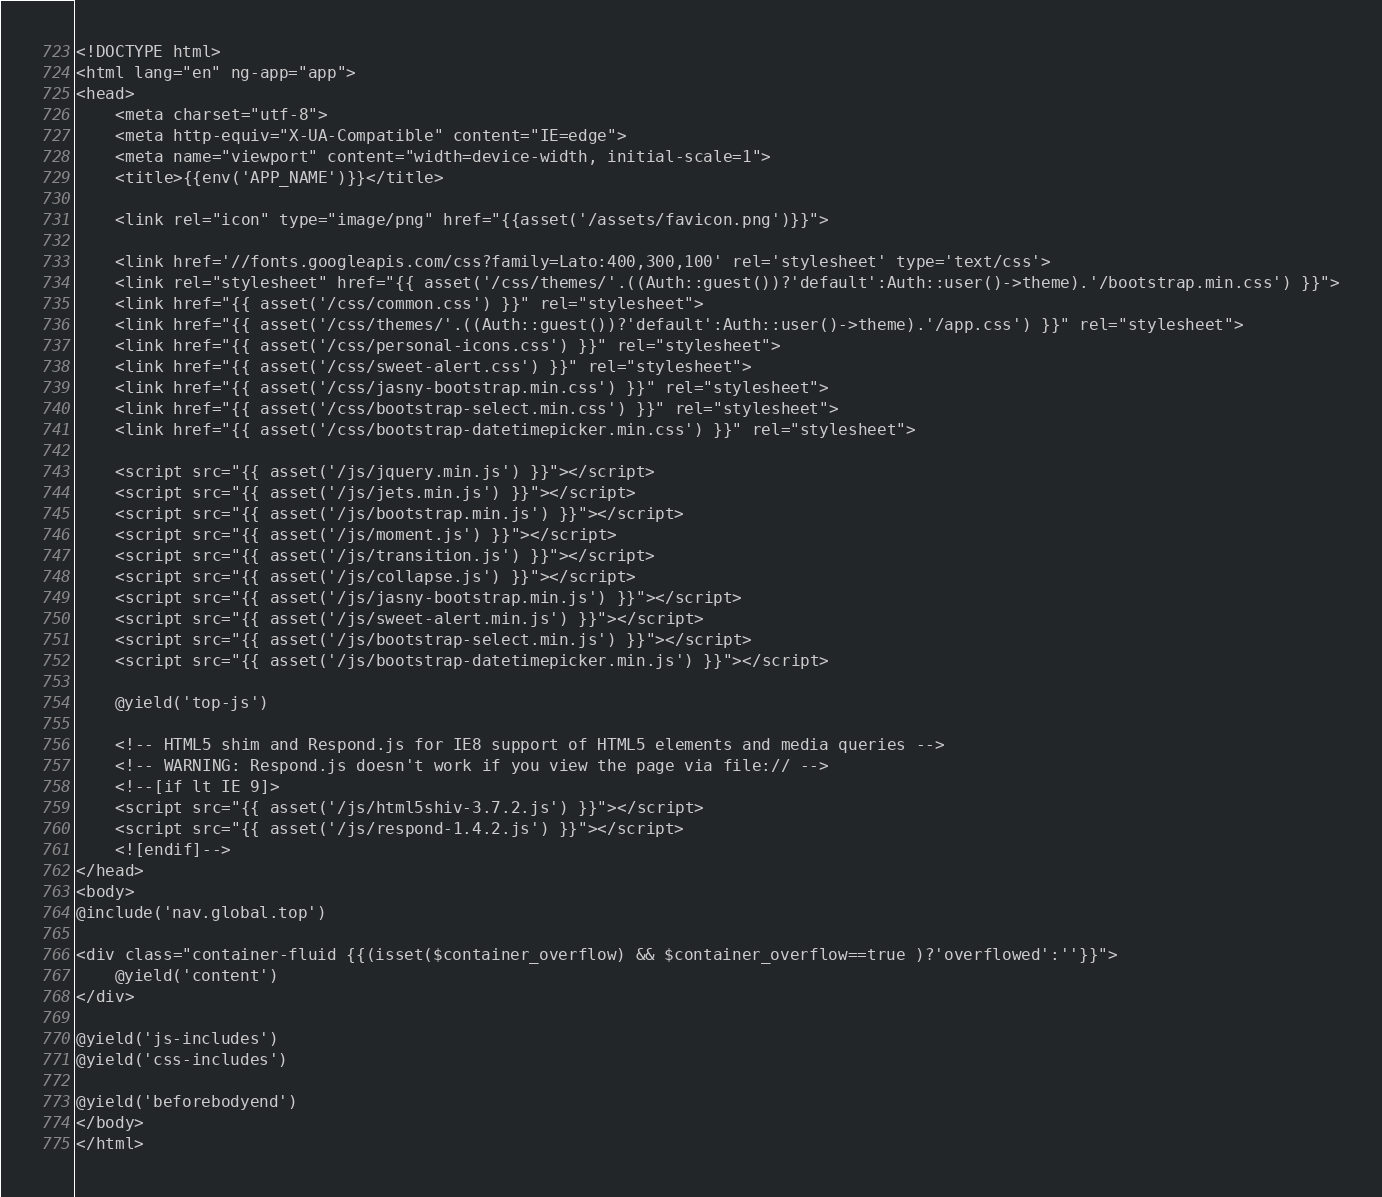Convert code to text. <code><loc_0><loc_0><loc_500><loc_500><_PHP_><!DOCTYPE html>
<html lang="en" ng-app="app">
<head>
	<meta charset="utf-8">
	<meta http-equiv="X-UA-Compatible" content="IE=edge">
	<meta name="viewport" content="width=device-width, initial-scale=1">
	<title>{{env('APP_NAME')}}</title>

	<link rel="icon" type="image/png" href="{{asset('/assets/favicon.png')}}">

	<link href='//fonts.googleapis.com/css?family=Lato:400,300,100' rel='stylesheet' type='text/css'>
	<link rel="stylesheet" href="{{ asset('/css/themes/'.((Auth::guest())?'default':Auth::user()->theme).'/bootstrap.min.css') }}">
	<link href="{{ asset('/css/common.css') }}" rel="stylesheet">
	<link href="{{ asset('/css/themes/'.((Auth::guest())?'default':Auth::user()->theme).'/app.css') }}" rel="stylesheet">
	<link href="{{ asset('/css/personal-icons.css') }}" rel="stylesheet">
	<link href="{{ asset('/css/sweet-alert.css') }}" rel="stylesheet">
	<link href="{{ asset('/css/jasny-bootstrap.min.css') }}" rel="stylesheet">
	<link href="{{ asset('/css/bootstrap-select.min.css') }}" rel="stylesheet">
	<link href="{{ asset('/css/bootstrap-datetimepicker.min.css') }}" rel="stylesheet">

	<script src="{{ asset('/js/jquery.min.js') }}"></script>
	<script src="{{ asset('/js/jets.min.js') }}"></script>
	<script src="{{ asset('/js/bootstrap.min.js') }}"></script>
	<script src="{{ asset('/js/moment.js') }}"></script>
	<script src="{{ asset('/js/transition.js') }}"></script>
	<script src="{{ asset('/js/collapse.js') }}"></script>
	<script src="{{ asset('/js/jasny-bootstrap.min.js') }}"></script>
	<script src="{{ asset('/js/sweet-alert.min.js') }}"></script>
	<script src="{{ asset('/js/bootstrap-select.min.js') }}"></script>
	<script src="{{ asset('/js/bootstrap-datetimepicker.min.js') }}"></script>

	@yield('top-js')

	<!-- HTML5 shim and Respond.js for IE8 support of HTML5 elements and media queries -->
	<!-- WARNING: Respond.js doesn't work if you view the page via file:// -->
	<!--[if lt IE 9]>
	<script src="{{ asset('/js/html5shiv-3.7.2.js') }}"></script>
	<script src="{{ asset('/js/respond-1.4.2.js') }}"></script>
	<![endif]-->
</head>
<body>
@include('nav.global.top')

<div class="container-fluid {{(isset($container_overflow) && $container_overflow==true )?'overflowed':''}}">
	@yield('content')
</div>

@yield('js-includes')
@yield('css-includes')

@yield('beforebodyend')
</body>
</html>
</code> 